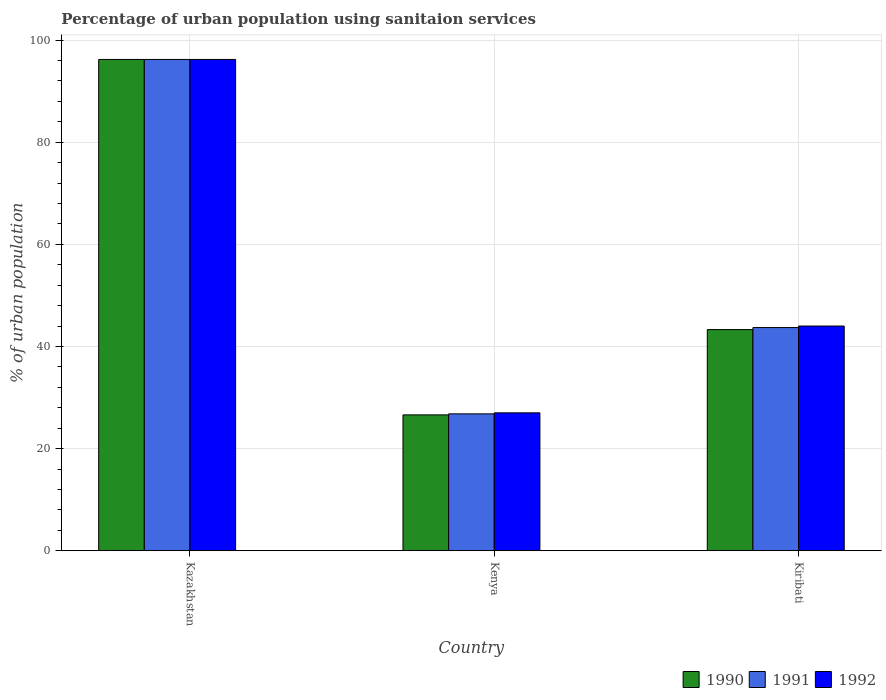How many groups of bars are there?
Offer a very short reply. 3. Are the number of bars per tick equal to the number of legend labels?
Provide a succinct answer. Yes. How many bars are there on the 3rd tick from the left?
Your answer should be compact. 3. How many bars are there on the 3rd tick from the right?
Provide a short and direct response. 3. What is the label of the 2nd group of bars from the left?
Your answer should be compact. Kenya. In how many cases, is the number of bars for a given country not equal to the number of legend labels?
Make the answer very short. 0. What is the percentage of urban population using sanitaion services in 1991 in Kenya?
Your response must be concise. 26.8. Across all countries, what is the maximum percentage of urban population using sanitaion services in 1990?
Provide a succinct answer. 96.2. In which country was the percentage of urban population using sanitaion services in 1992 maximum?
Your answer should be compact. Kazakhstan. In which country was the percentage of urban population using sanitaion services in 1990 minimum?
Provide a succinct answer. Kenya. What is the total percentage of urban population using sanitaion services in 1990 in the graph?
Offer a very short reply. 166.1. What is the difference between the percentage of urban population using sanitaion services in 1992 in Kazakhstan and that in Kiribati?
Give a very brief answer. 52.2. What is the difference between the percentage of urban population using sanitaion services in 1992 in Kenya and the percentage of urban population using sanitaion services in 1991 in Kiribati?
Provide a succinct answer. -16.7. What is the average percentage of urban population using sanitaion services in 1990 per country?
Your answer should be compact. 55.37. What is the difference between the percentage of urban population using sanitaion services of/in 1991 and percentage of urban population using sanitaion services of/in 1992 in Kiribati?
Offer a very short reply. -0.3. In how many countries, is the percentage of urban population using sanitaion services in 1991 greater than 88 %?
Give a very brief answer. 1. What is the ratio of the percentage of urban population using sanitaion services in 1992 in Kenya to that in Kiribati?
Your answer should be very brief. 0.61. Is the percentage of urban population using sanitaion services in 1990 in Kazakhstan less than that in Kiribati?
Provide a short and direct response. No. What is the difference between the highest and the second highest percentage of urban population using sanitaion services in 1990?
Offer a terse response. 69.6. What is the difference between the highest and the lowest percentage of urban population using sanitaion services in 1992?
Your answer should be compact. 69.2. In how many countries, is the percentage of urban population using sanitaion services in 1992 greater than the average percentage of urban population using sanitaion services in 1992 taken over all countries?
Provide a succinct answer. 1. What does the 1st bar from the left in Kazakhstan represents?
Ensure brevity in your answer.  1990. What does the 3rd bar from the right in Kenya represents?
Give a very brief answer. 1990. Is it the case that in every country, the sum of the percentage of urban population using sanitaion services in 1992 and percentage of urban population using sanitaion services in 1990 is greater than the percentage of urban population using sanitaion services in 1991?
Provide a short and direct response. Yes. How many bars are there?
Give a very brief answer. 9. How many countries are there in the graph?
Ensure brevity in your answer.  3. What is the difference between two consecutive major ticks on the Y-axis?
Make the answer very short. 20. Does the graph contain any zero values?
Offer a very short reply. No. Does the graph contain grids?
Make the answer very short. Yes. Where does the legend appear in the graph?
Provide a succinct answer. Bottom right. How many legend labels are there?
Keep it short and to the point. 3. What is the title of the graph?
Provide a succinct answer. Percentage of urban population using sanitaion services. What is the label or title of the Y-axis?
Your answer should be compact. % of urban population. What is the % of urban population in 1990 in Kazakhstan?
Your answer should be compact. 96.2. What is the % of urban population of 1991 in Kazakhstan?
Give a very brief answer. 96.2. What is the % of urban population in 1992 in Kazakhstan?
Ensure brevity in your answer.  96.2. What is the % of urban population in 1990 in Kenya?
Offer a terse response. 26.6. What is the % of urban population in 1991 in Kenya?
Provide a succinct answer. 26.8. What is the % of urban population of 1992 in Kenya?
Offer a very short reply. 27. What is the % of urban population in 1990 in Kiribati?
Your answer should be very brief. 43.3. What is the % of urban population in 1991 in Kiribati?
Ensure brevity in your answer.  43.7. Across all countries, what is the maximum % of urban population in 1990?
Provide a succinct answer. 96.2. Across all countries, what is the maximum % of urban population of 1991?
Offer a very short reply. 96.2. Across all countries, what is the maximum % of urban population in 1992?
Keep it short and to the point. 96.2. Across all countries, what is the minimum % of urban population in 1990?
Provide a short and direct response. 26.6. Across all countries, what is the minimum % of urban population of 1991?
Offer a very short reply. 26.8. What is the total % of urban population in 1990 in the graph?
Make the answer very short. 166.1. What is the total % of urban population in 1991 in the graph?
Offer a terse response. 166.7. What is the total % of urban population of 1992 in the graph?
Provide a succinct answer. 167.2. What is the difference between the % of urban population in 1990 in Kazakhstan and that in Kenya?
Your answer should be compact. 69.6. What is the difference between the % of urban population in 1991 in Kazakhstan and that in Kenya?
Provide a short and direct response. 69.4. What is the difference between the % of urban population in 1992 in Kazakhstan and that in Kenya?
Give a very brief answer. 69.2. What is the difference between the % of urban population in 1990 in Kazakhstan and that in Kiribati?
Give a very brief answer. 52.9. What is the difference between the % of urban population of 1991 in Kazakhstan and that in Kiribati?
Provide a succinct answer. 52.5. What is the difference between the % of urban population in 1992 in Kazakhstan and that in Kiribati?
Keep it short and to the point. 52.2. What is the difference between the % of urban population in 1990 in Kenya and that in Kiribati?
Your answer should be compact. -16.7. What is the difference between the % of urban population of 1991 in Kenya and that in Kiribati?
Ensure brevity in your answer.  -16.9. What is the difference between the % of urban population of 1990 in Kazakhstan and the % of urban population of 1991 in Kenya?
Your answer should be compact. 69.4. What is the difference between the % of urban population in 1990 in Kazakhstan and the % of urban population in 1992 in Kenya?
Provide a succinct answer. 69.2. What is the difference between the % of urban population of 1991 in Kazakhstan and the % of urban population of 1992 in Kenya?
Offer a terse response. 69.2. What is the difference between the % of urban population in 1990 in Kazakhstan and the % of urban population in 1991 in Kiribati?
Your response must be concise. 52.5. What is the difference between the % of urban population in 1990 in Kazakhstan and the % of urban population in 1992 in Kiribati?
Give a very brief answer. 52.2. What is the difference between the % of urban population in 1991 in Kazakhstan and the % of urban population in 1992 in Kiribati?
Give a very brief answer. 52.2. What is the difference between the % of urban population of 1990 in Kenya and the % of urban population of 1991 in Kiribati?
Keep it short and to the point. -17.1. What is the difference between the % of urban population in 1990 in Kenya and the % of urban population in 1992 in Kiribati?
Your response must be concise. -17.4. What is the difference between the % of urban population of 1991 in Kenya and the % of urban population of 1992 in Kiribati?
Offer a very short reply. -17.2. What is the average % of urban population of 1990 per country?
Offer a very short reply. 55.37. What is the average % of urban population in 1991 per country?
Offer a terse response. 55.57. What is the average % of urban population of 1992 per country?
Keep it short and to the point. 55.73. What is the difference between the % of urban population in 1990 and % of urban population in 1991 in Kazakhstan?
Your response must be concise. 0. What is the difference between the % of urban population of 1991 and % of urban population of 1992 in Kazakhstan?
Offer a very short reply. 0. What is the difference between the % of urban population in 1990 and % of urban population in 1991 in Kenya?
Offer a terse response. -0.2. What is the difference between the % of urban population in 1990 and % of urban population in 1992 in Kiribati?
Your answer should be compact. -0.7. What is the ratio of the % of urban population of 1990 in Kazakhstan to that in Kenya?
Provide a short and direct response. 3.62. What is the ratio of the % of urban population of 1991 in Kazakhstan to that in Kenya?
Provide a short and direct response. 3.59. What is the ratio of the % of urban population in 1992 in Kazakhstan to that in Kenya?
Your answer should be very brief. 3.56. What is the ratio of the % of urban population of 1990 in Kazakhstan to that in Kiribati?
Ensure brevity in your answer.  2.22. What is the ratio of the % of urban population of 1991 in Kazakhstan to that in Kiribati?
Offer a very short reply. 2.2. What is the ratio of the % of urban population of 1992 in Kazakhstan to that in Kiribati?
Provide a succinct answer. 2.19. What is the ratio of the % of urban population in 1990 in Kenya to that in Kiribati?
Provide a succinct answer. 0.61. What is the ratio of the % of urban population of 1991 in Kenya to that in Kiribati?
Your response must be concise. 0.61. What is the ratio of the % of urban population in 1992 in Kenya to that in Kiribati?
Your answer should be very brief. 0.61. What is the difference between the highest and the second highest % of urban population of 1990?
Offer a terse response. 52.9. What is the difference between the highest and the second highest % of urban population in 1991?
Ensure brevity in your answer.  52.5. What is the difference between the highest and the second highest % of urban population of 1992?
Give a very brief answer. 52.2. What is the difference between the highest and the lowest % of urban population of 1990?
Provide a succinct answer. 69.6. What is the difference between the highest and the lowest % of urban population in 1991?
Ensure brevity in your answer.  69.4. What is the difference between the highest and the lowest % of urban population of 1992?
Offer a very short reply. 69.2. 